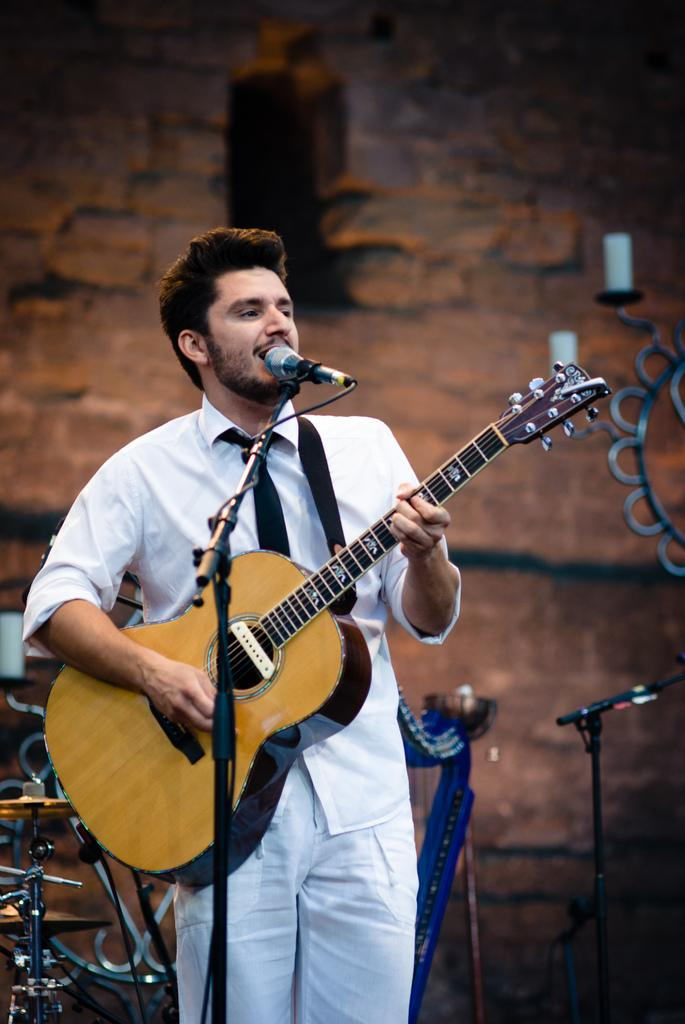What is the person in the image doing? The person is standing, holding a guitar, and singing. What object is the person holding in the image? The person is holding a guitar. What is the purpose of the microphone with a stand in the image? The microphone with a stand is likely used for amplifying the person's voice while singing. What can be seen in the background of the image? There is a wall in the background of the image. What type of coal is being used to fuel the person's singing in the image? There is no coal present in the image, and coal is not used to fuel singing. 